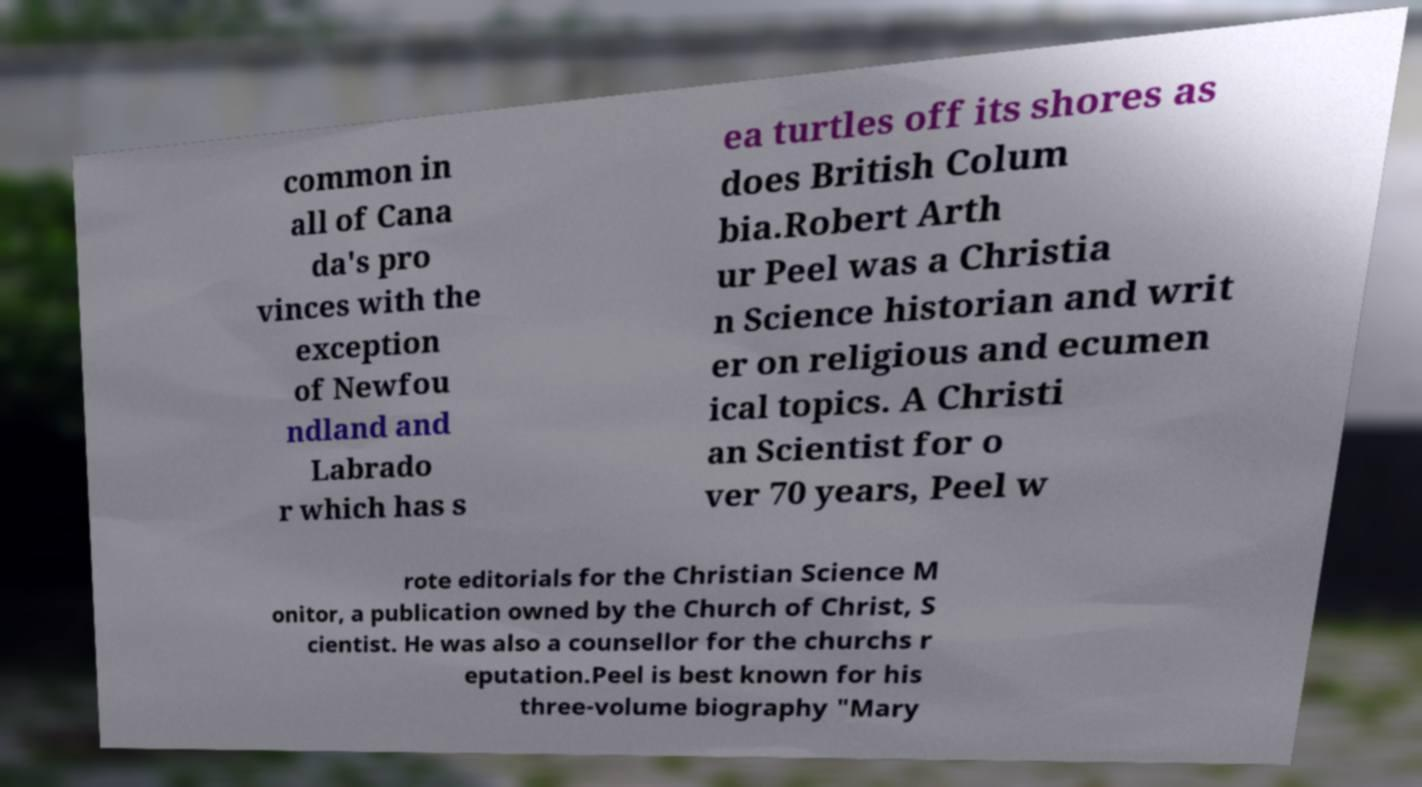Please read and relay the text visible in this image. What does it say? common in all of Cana da's pro vinces with the exception of Newfou ndland and Labrado r which has s ea turtles off its shores as does British Colum bia.Robert Arth ur Peel was a Christia n Science historian and writ er on religious and ecumen ical topics. A Christi an Scientist for o ver 70 years, Peel w rote editorials for the Christian Science M onitor, a publication owned by the Church of Christ, S cientist. He was also a counsellor for the churchs r eputation.Peel is best known for his three-volume biography "Mary 